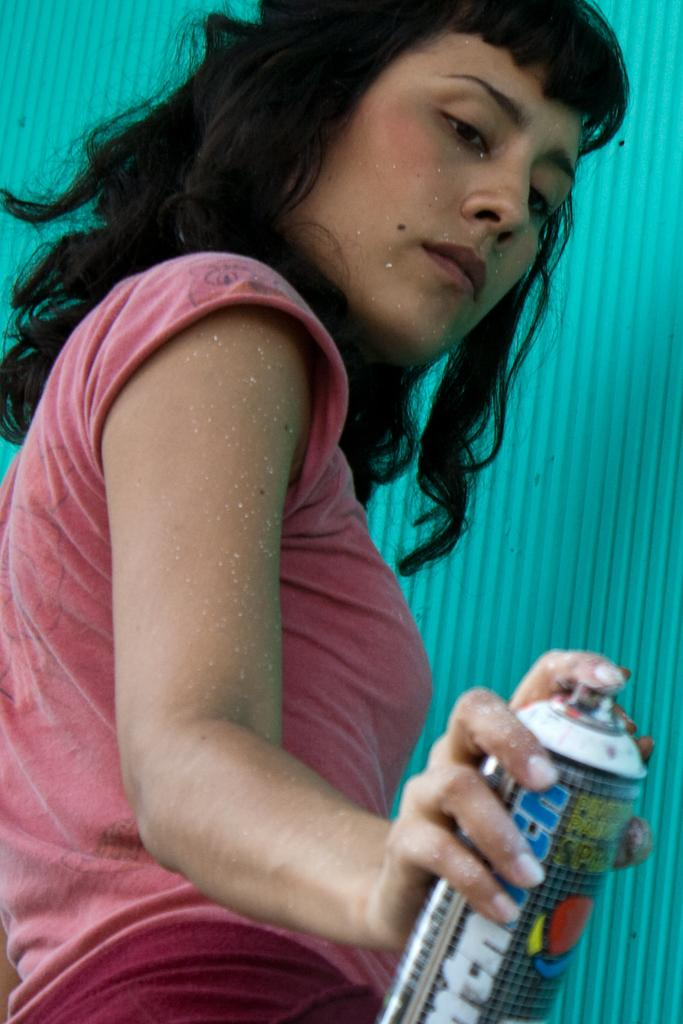What is the main subject of the image? The main subject of the image is a woman. What is the woman holding in the image? The woman is holding a bottle. How many pages are in the book that the woman is reading in the image? There is no book present in the image, and therefore no pages to count. 